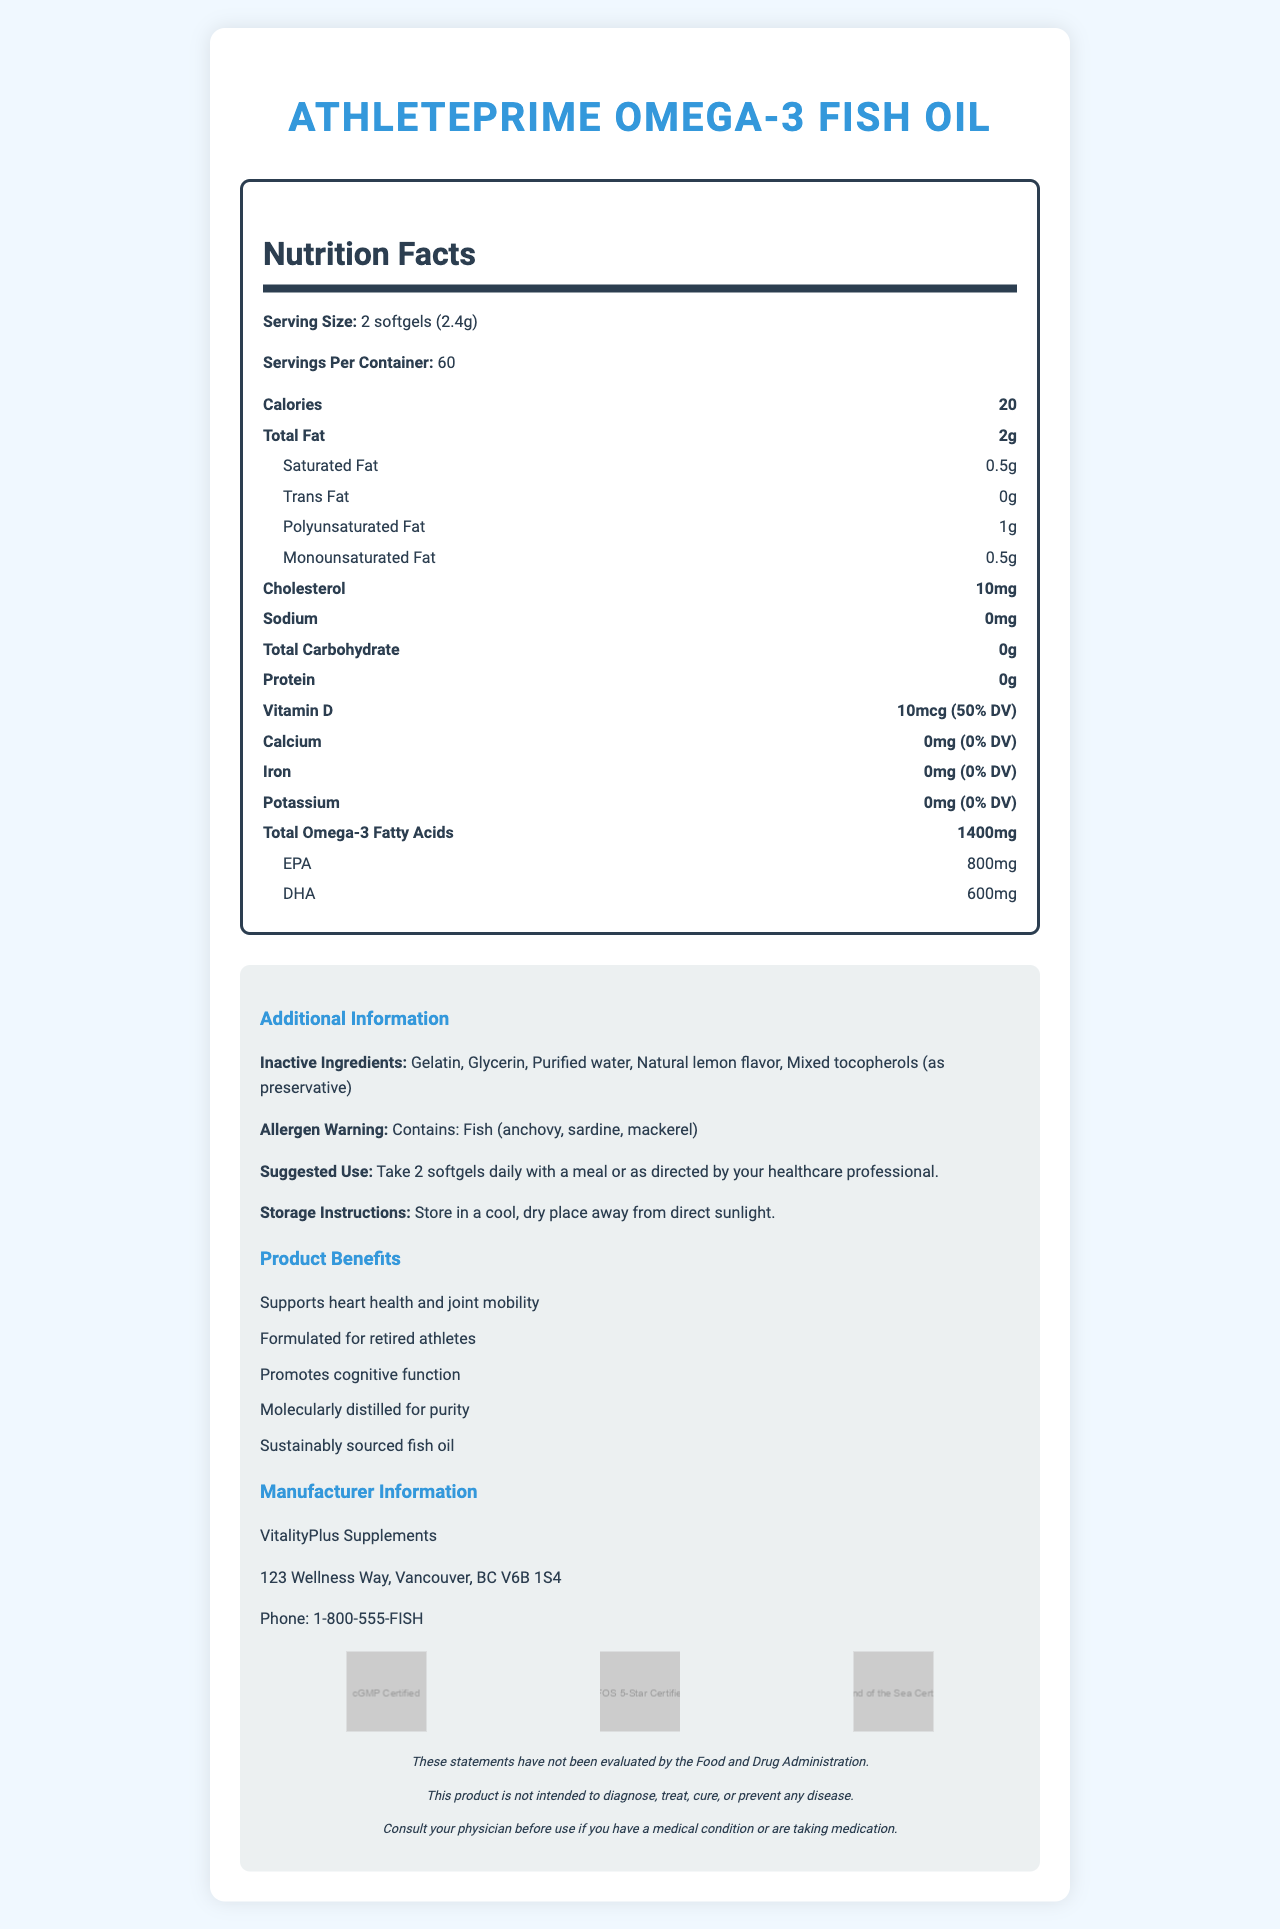what is the serving size for AthletePrime Omega-3 Fish Oil? The serving size is clearly mentioned as "2 softgels (2.4g)" under the Nutrition Facts section.
Answer: 2 softgels (2.4g) how many servings does one container of AthletePrime Omega-3 Fish Oil have? The document specifies that there are "60 servings per container."
Answer: 60 servings how many calories are in one serving? The Nutrition Facts label states that each serving contains 20 calories.
Answer: 20 calories What is the amount of total fat in one serving? The nutrition label lists "Total Fat" as 2g per serving.
Answer: 2g how much saturated fat is in one serving? The saturated fat content per serving is listed as 0.5g in the nutrition label.
Answer: 0.5g what are the inactive ingredients in the supplement? The document includes a list of inactive ingredients under the "Additional Information" section.
Answer: Gelatin, Glycerin, Purified water, Natural lemon flavor, Mixed tocopherols (as preservative) what is the total amount of Omega-3 fatty acids per serving? The label states that each serving contains 1400mg of total Omega-3 fatty acids.
Answer: 1400mg How much EPA is in each serving of the supplement? The nutrition label clearly mentions that EPA content per serving is 800mg.
Answer: 800mg which of the following ingredients is used as a preservative: a. Gelatin, b. Mixed tocopherols, c. Natural honey, d. Glycerin? The list of inactive ingredients shows "Mixed tocopherols (as preservative)," indicating it is used as a preservative.
Answer: b. Mixed tocopherols how much vitamin D is present per serving? a. 10mcg, b. 20mcg, c. 5mcg, d. 15mcg The nutrition label lists Vitamin D content as 10mcg per serving.
Answer: a. 10mcg is the product safe for people who have fish allergies? The allergen warning specifies that the product contains fish (anchovy, sardine, mackerel).
Answer: No does the product have any carbohydrates? The nutrition label indicates "Total Carbohydrate" as 0g per serving.
Answer: No what is the primary health benefit of taking AthletePrime Omega-3 Fish Oil for retired athletes? The additional information section states that the product "Supports heart health and joint mobility."
Answer: Supports heart health and joint mobility can you determine the price of the supplement from the document? The document does not provide any information regarding the price of the supplement.
Answer: Not enough information describe the main purpose of the AthletePrime Omega-3 Fish Oil supplement as presented in the document. The explanation for the summary includes key benefits, specific nutrient details, and additional information about the formulation mentioned in the document.
Answer: The main purpose of the AthletePrime Omega-3 Fish Oil supplement is to support heart health, joint mobility, and cognitive function, particularly formulated for retired athletes. It is molecularly distilled for purity and sustainably sourced. The supplement provides 1400mg of Omega-3 fatty acids per serving with 800mg EPA and 600mg DHA, and it includes additional ingredients like gelatin, glycerin, and natural lemon flavor. 